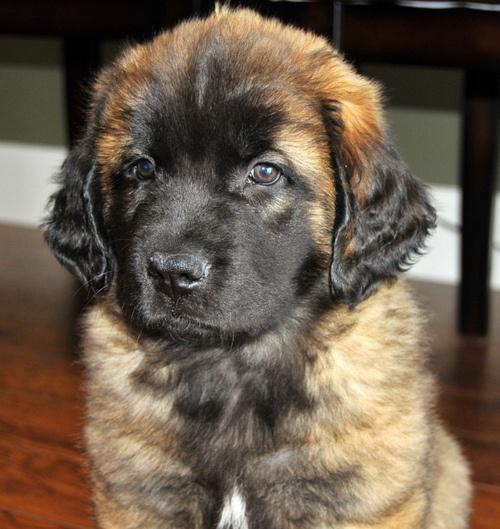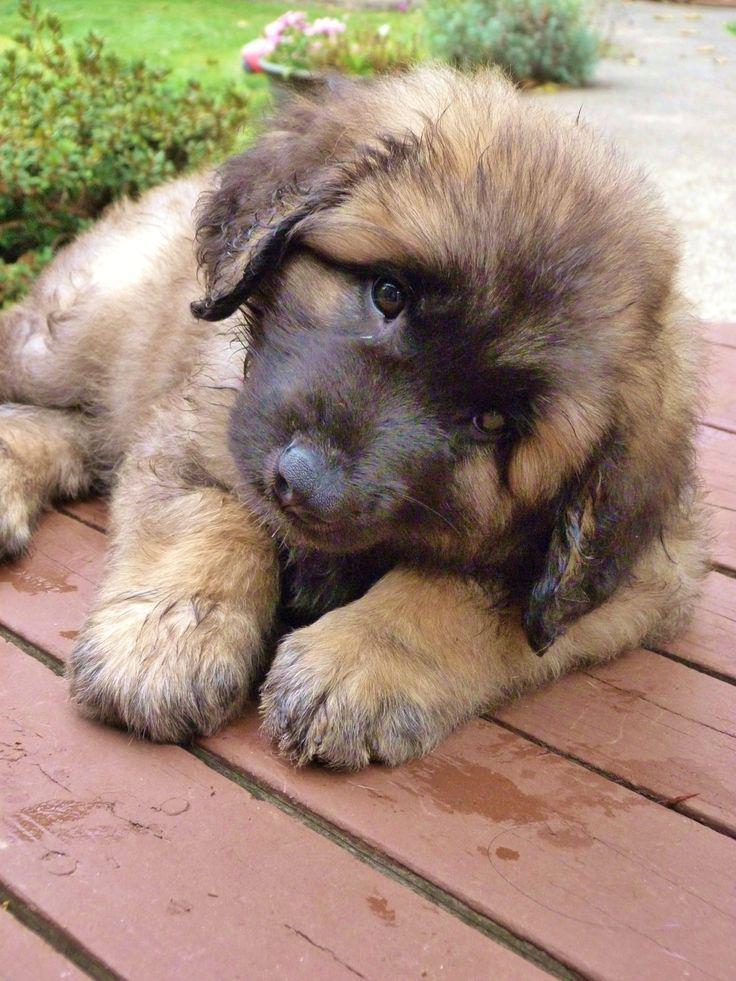The first image is the image on the left, the second image is the image on the right. Given the left and right images, does the statement "The dog in the left photo has its tongue out." hold true? Answer yes or no. No. 